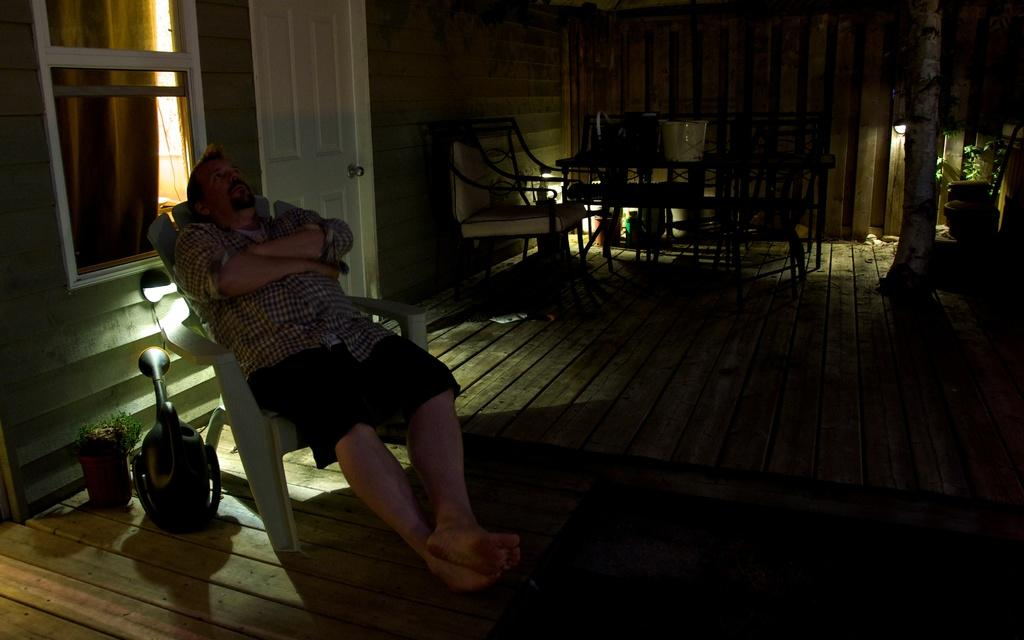Who or what is in the image? There is a person in the image. What is the person doing in the image? The person is resting on a chair. What can be seen on the left side of the person? There is a plant on the left side of the person. What is visible behind the person? There is a window and a door behind the person. What is on the right side of the person? There is a table and chairs on the right side of the person. What type of stone is the person using as a hat in the image? There is no stone or hat present in the image. How many cups can be seen on the table in the image? There is no mention of cups in the image; only a table is mentioned. 